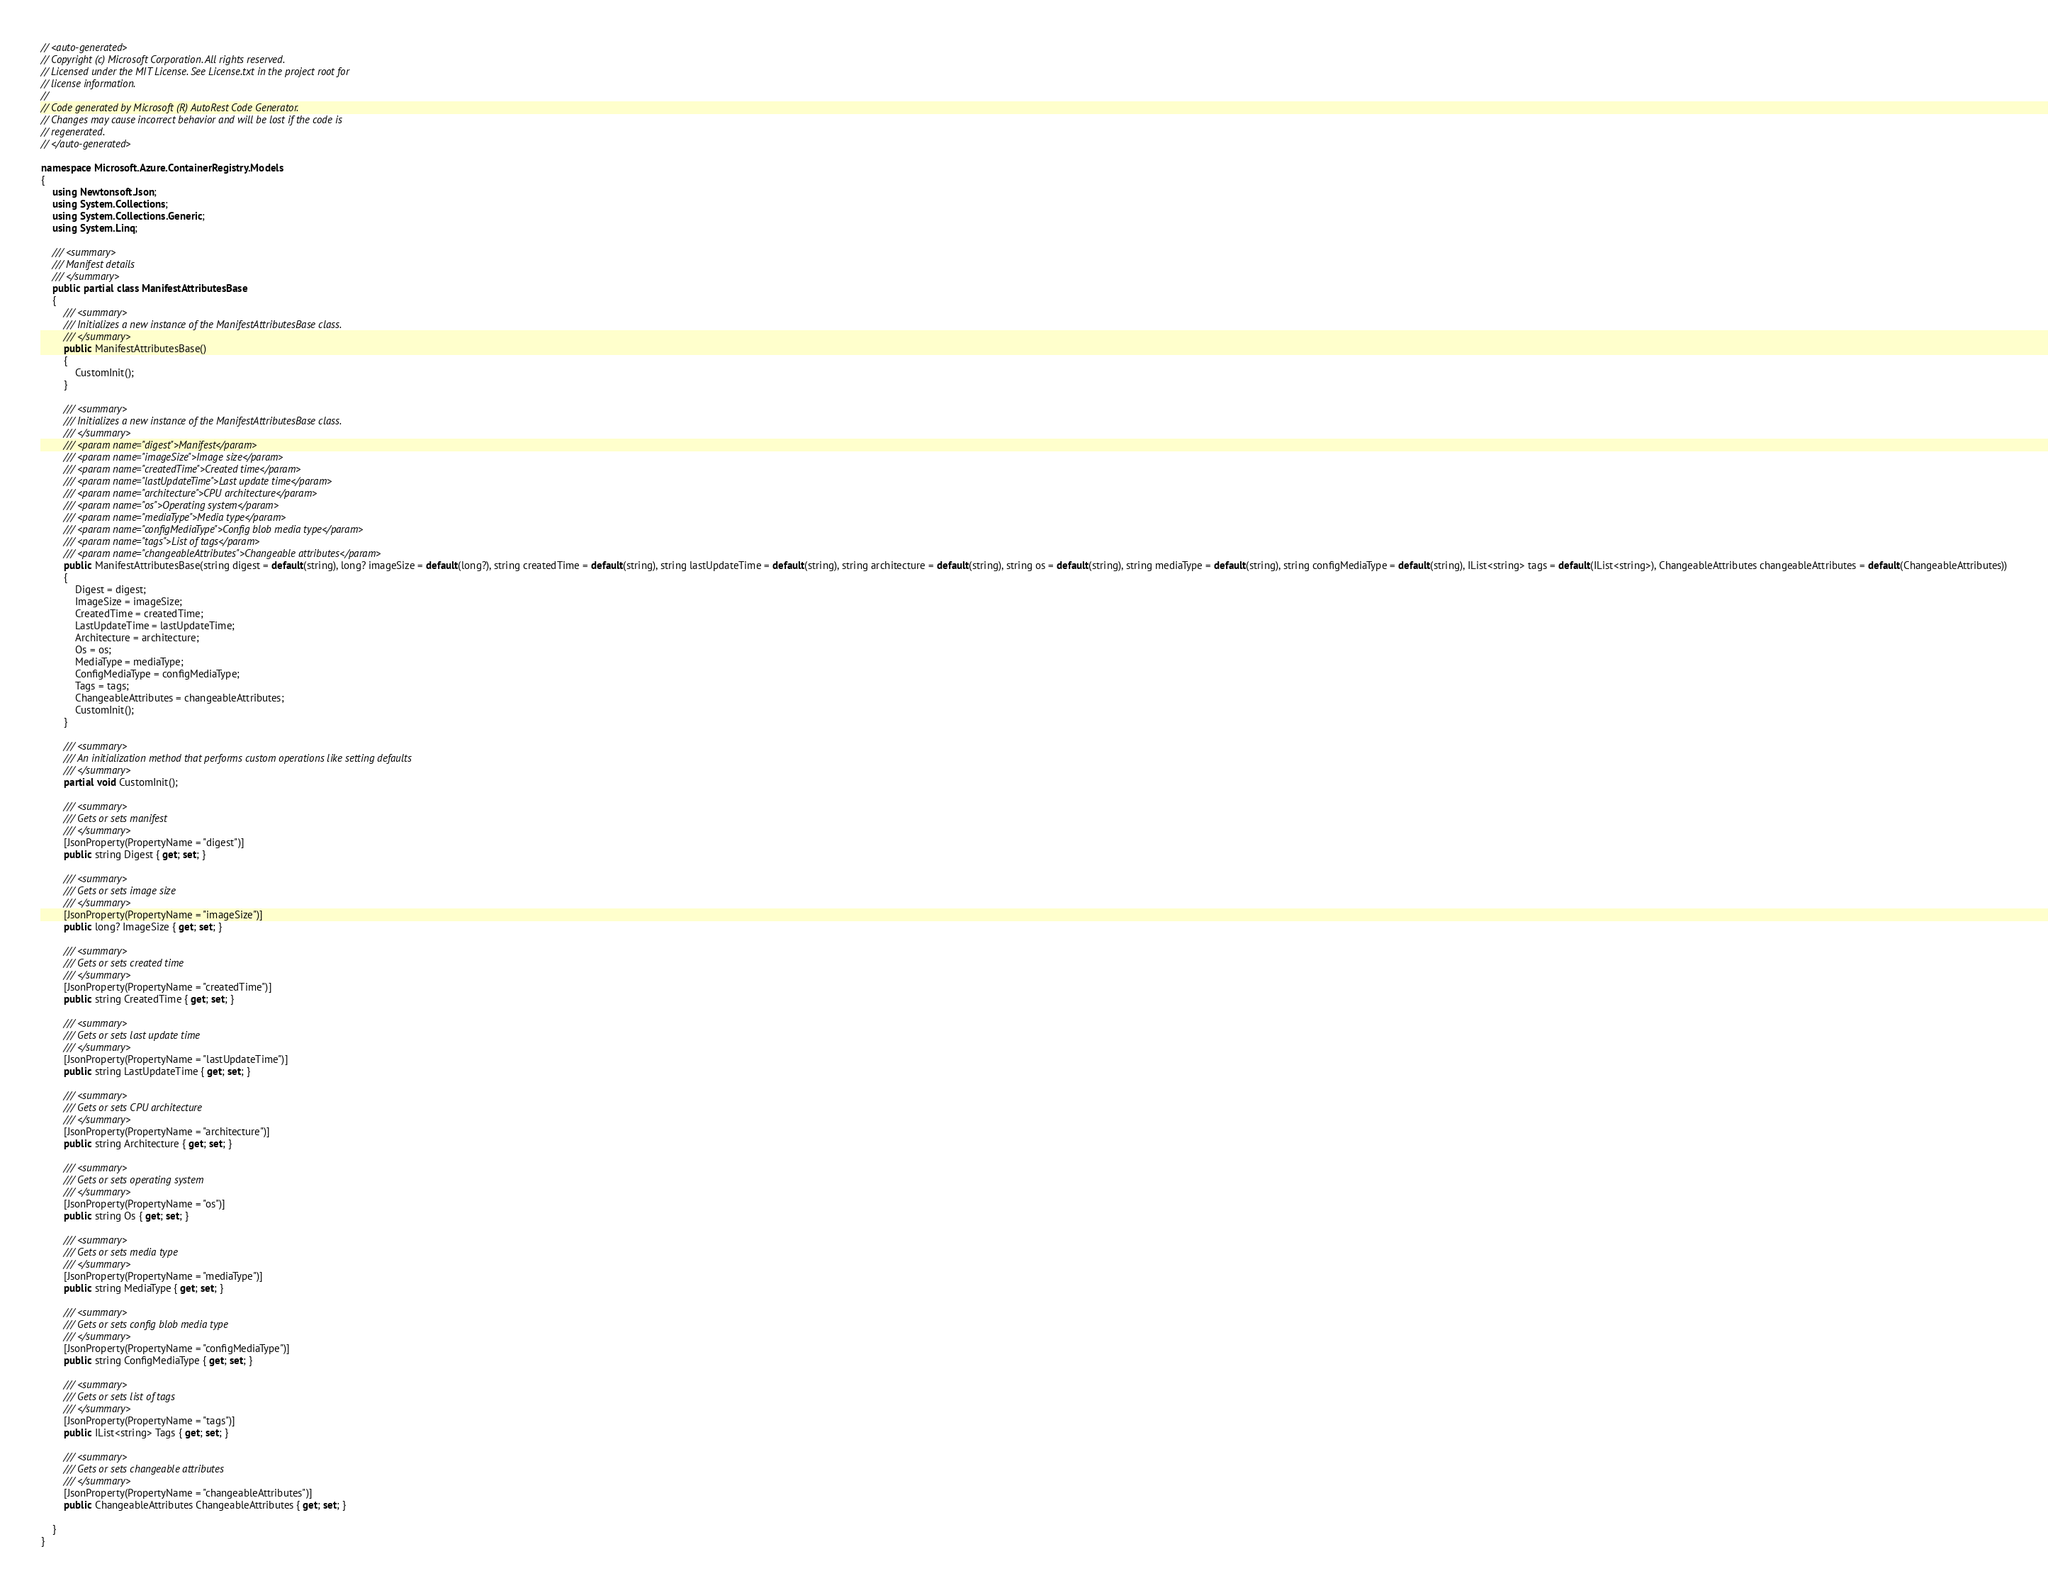Convert code to text. <code><loc_0><loc_0><loc_500><loc_500><_C#_>// <auto-generated>
// Copyright (c) Microsoft Corporation. All rights reserved.
// Licensed under the MIT License. See License.txt in the project root for
// license information.
//
// Code generated by Microsoft (R) AutoRest Code Generator.
// Changes may cause incorrect behavior and will be lost if the code is
// regenerated.
// </auto-generated>

namespace Microsoft.Azure.ContainerRegistry.Models
{
    using Newtonsoft.Json;
    using System.Collections;
    using System.Collections.Generic;
    using System.Linq;

    /// <summary>
    /// Manifest details
    /// </summary>
    public partial class ManifestAttributesBase
    {
        /// <summary>
        /// Initializes a new instance of the ManifestAttributesBase class.
        /// </summary>
        public ManifestAttributesBase()
        {
            CustomInit();
        }

        /// <summary>
        /// Initializes a new instance of the ManifestAttributesBase class.
        /// </summary>
        /// <param name="digest">Manifest</param>
        /// <param name="imageSize">Image size</param>
        /// <param name="createdTime">Created time</param>
        /// <param name="lastUpdateTime">Last update time</param>
        /// <param name="architecture">CPU architecture</param>
        /// <param name="os">Operating system</param>
        /// <param name="mediaType">Media type</param>
        /// <param name="configMediaType">Config blob media type</param>
        /// <param name="tags">List of tags</param>
        /// <param name="changeableAttributes">Changeable attributes</param>
        public ManifestAttributesBase(string digest = default(string), long? imageSize = default(long?), string createdTime = default(string), string lastUpdateTime = default(string), string architecture = default(string), string os = default(string), string mediaType = default(string), string configMediaType = default(string), IList<string> tags = default(IList<string>), ChangeableAttributes changeableAttributes = default(ChangeableAttributes))
        {
            Digest = digest;
            ImageSize = imageSize;
            CreatedTime = createdTime;
            LastUpdateTime = lastUpdateTime;
            Architecture = architecture;
            Os = os;
            MediaType = mediaType;
            ConfigMediaType = configMediaType;
            Tags = tags;
            ChangeableAttributes = changeableAttributes;
            CustomInit();
        }

        /// <summary>
        /// An initialization method that performs custom operations like setting defaults
        /// </summary>
        partial void CustomInit();

        /// <summary>
        /// Gets or sets manifest
        /// </summary>
        [JsonProperty(PropertyName = "digest")]
        public string Digest { get; set; }

        /// <summary>
        /// Gets or sets image size
        /// </summary>
        [JsonProperty(PropertyName = "imageSize")]
        public long? ImageSize { get; set; }

        /// <summary>
        /// Gets or sets created time
        /// </summary>
        [JsonProperty(PropertyName = "createdTime")]
        public string CreatedTime { get; set; }

        /// <summary>
        /// Gets or sets last update time
        /// </summary>
        [JsonProperty(PropertyName = "lastUpdateTime")]
        public string LastUpdateTime { get; set; }

        /// <summary>
        /// Gets or sets CPU architecture
        /// </summary>
        [JsonProperty(PropertyName = "architecture")]
        public string Architecture { get; set; }

        /// <summary>
        /// Gets or sets operating system
        /// </summary>
        [JsonProperty(PropertyName = "os")]
        public string Os { get; set; }

        /// <summary>
        /// Gets or sets media type
        /// </summary>
        [JsonProperty(PropertyName = "mediaType")]
        public string MediaType { get; set; }

        /// <summary>
        /// Gets or sets config blob media type
        /// </summary>
        [JsonProperty(PropertyName = "configMediaType")]
        public string ConfigMediaType { get; set; }

        /// <summary>
        /// Gets or sets list of tags
        /// </summary>
        [JsonProperty(PropertyName = "tags")]
        public IList<string> Tags { get; set; }

        /// <summary>
        /// Gets or sets changeable attributes
        /// </summary>
        [JsonProperty(PropertyName = "changeableAttributes")]
        public ChangeableAttributes ChangeableAttributes { get; set; }

    }
}
</code> 